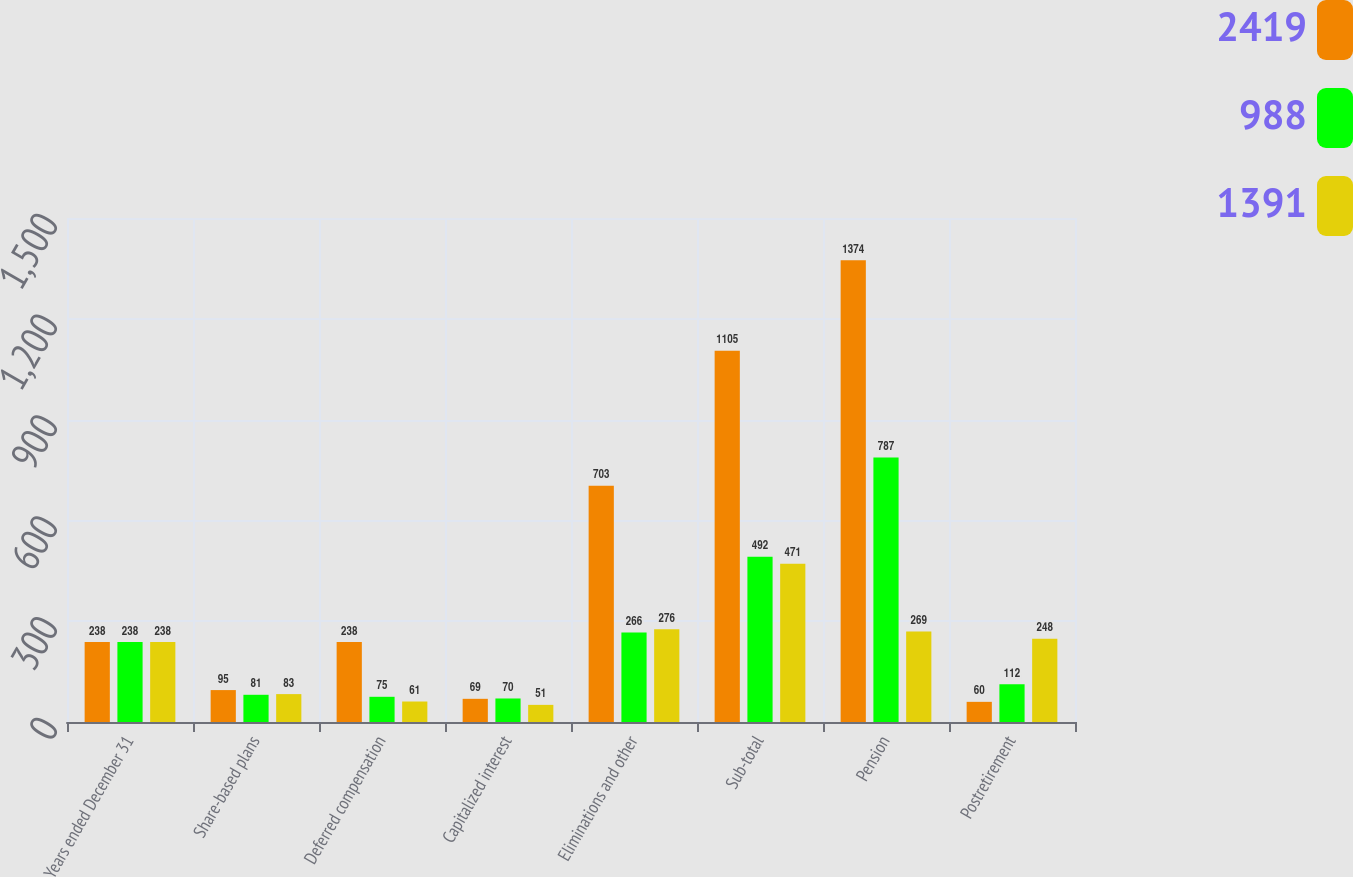Convert chart to OTSL. <chart><loc_0><loc_0><loc_500><loc_500><stacked_bar_chart><ecel><fcel>Years ended December 31<fcel>Share-based plans<fcel>Deferred compensation<fcel>Capitalized interest<fcel>Eliminations and other<fcel>Sub-total<fcel>Pension<fcel>Postretirement<nl><fcel>2419<fcel>238<fcel>95<fcel>238<fcel>69<fcel>703<fcel>1105<fcel>1374<fcel>60<nl><fcel>988<fcel>238<fcel>81<fcel>75<fcel>70<fcel>266<fcel>492<fcel>787<fcel>112<nl><fcel>1391<fcel>238<fcel>83<fcel>61<fcel>51<fcel>276<fcel>471<fcel>269<fcel>248<nl></chart> 